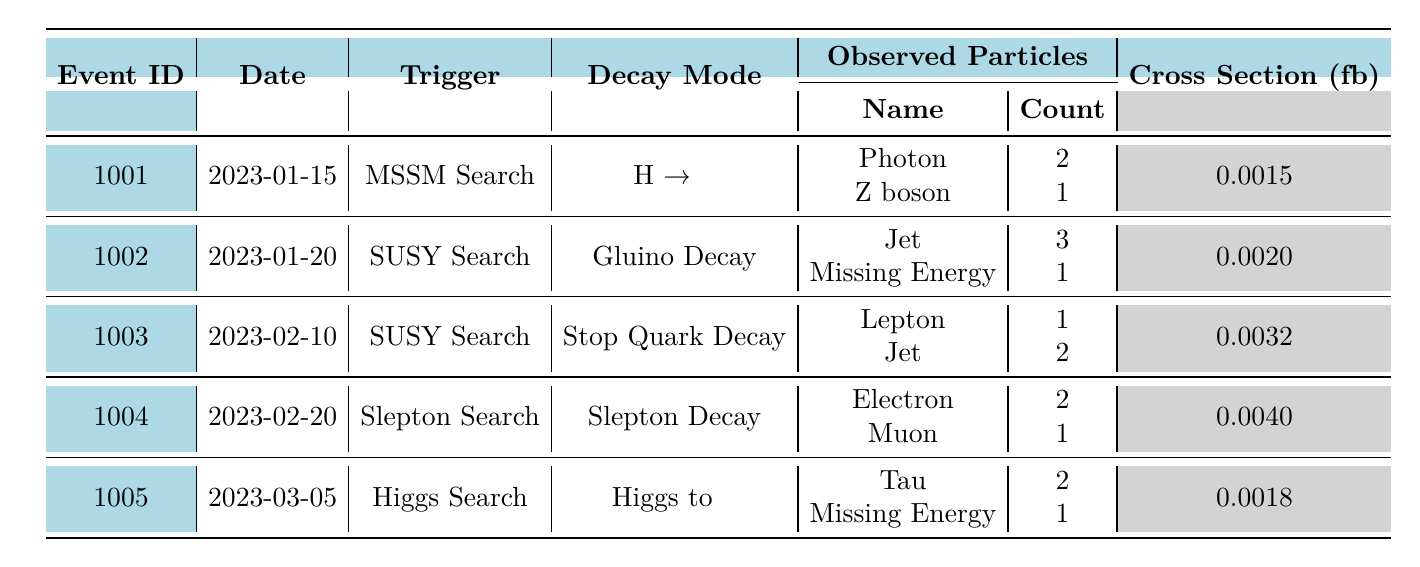What is the date of the first event recorded? The first event in the table has the Event ID 1001, with a corresponding date of 2023-01-15.
Answer: 2023-01-15 What was the trigger for the event with ID 1004? According to the table, the trigger for Event ID 1004 is listed as "Slepton Search."
Answer: Slepton Search How many jets were observed in the event with ID 1002? The event with ID 1002 shows that there were 3 jets observed.
Answer: 3 What is the decay mode of the event with ID 1003? Looking at the details of Event ID 1003, the decay mode is "Stop Quark Decay."
Answer: Stop Quark Decay What is the total count of observed particles in Event ID 1005? In Event ID 1005, there are 2 Tau particles and 1 missing energy recorded, summing up to a total count of 3 observed particles.
Answer: 3 Which event has the highest cross section, and what is its value? By examining the cross-section values, Event ID 1004 has the highest value at 0.004 fb.
Answer: 0.004 fb Is there any event that recorded "Missing Energy" as an observed particle? Yes, events 1002 and 1005 both list "Missing Energy" among the observed particles.
Answer: Yes Calculate the average cross-section of all recorded events. The cross sections for all events are: 0.0015, 0.002, 0.0032, 0.004, and 0.0018. Summing these gives 0.0125. Dividing by 5 (the number of events) results in an average of 0.0025 fb.
Answer: 0.0025 fb What is the observed energy range for the second event's jets? The second event's jets have observed energies of 45 GeV, 50 GeV, and 60 GeV, making the range from 45 to 60 GeV.
Answer: 45 to 60 GeV Which event includes a decay involving tau particles? The event that includes a decay involving tau particles is Event ID 1005, which reports "Higgs to ττ."
Answer: Event ID 1005 